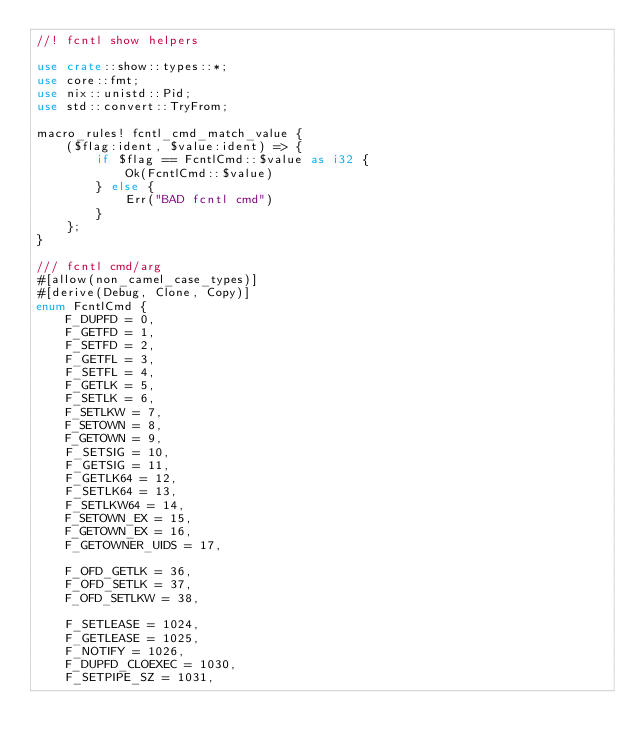Convert code to text. <code><loc_0><loc_0><loc_500><loc_500><_Rust_>//! fcntl show helpers

use crate::show::types::*;
use core::fmt;
use nix::unistd::Pid;
use std::convert::TryFrom;

macro_rules! fcntl_cmd_match_value {
    ($flag:ident, $value:ident) => {
        if $flag == FcntlCmd::$value as i32 {
            Ok(FcntlCmd::$value)
        } else {
            Err("BAD fcntl cmd")
        }
    };
}

/// fcntl cmd/arg
#[allow(non_camel_case_types)]
#[derive(Debug, Clone, Copy)]
enum FcntlCmd {
    F_DUPFD = 0,
    F_GETFD = 1,
    F_SETFD = 2,
    F_GETFL = 3,
    F_SETFL = 4,
    F_GETLK = 5,
    F_SETLK = 6,
    F_SETLKW = 7,
    F_SETOWN = 8,
    F_GETOWN = 9,
    F_SETSIG = 10,
    F_GETSIG = 11,
    F_GETLK64 = 12,
    F_SETLK64 = 13,
    F_SETLKW64 = 14,
    F_SETOWN_EX = 15,
    F_GETOWN_EX = 16,
    F_GETOWNER_UIDS = 17,

    F_OFD_GETLK = 36,
    F_OFD_SETLK = 37,
    F_OFD_SETLKW = 38,

    F_SETLEASE = 1024,
    F_GETLEASE = 1025,
    F_NOTIFY = 1026,
    F_DUPFD_CLOEXEC = 1030,
    F_SETPIPE_SZ = 1031,</code> 